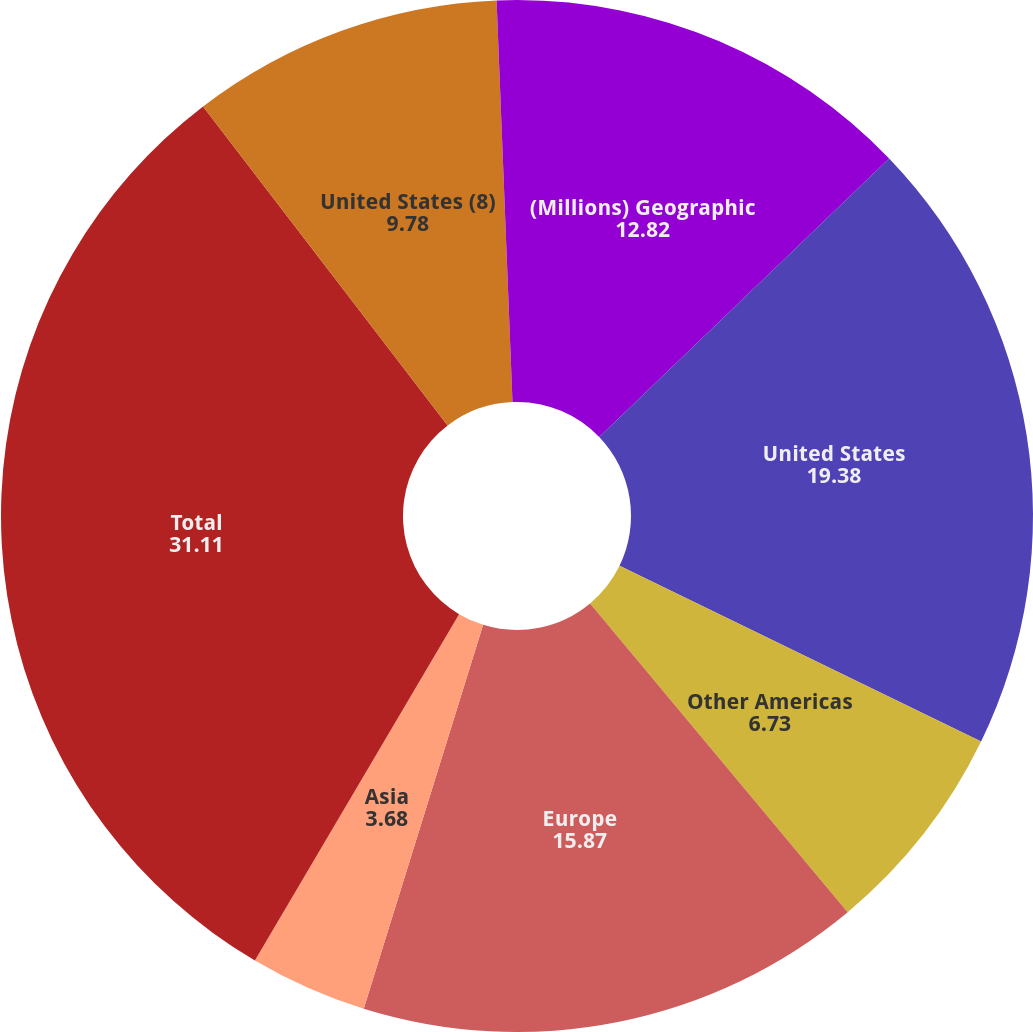Convert chart. <chart><loc_0><loc_0><loc_500><loc_500><pie_chart><fcel>(Millions) Geographic<fcel>United States<fcel>Other Americas<fcel>Europe<fcel>Asia<fcel>Total<fcel>United States (8)<fcel>Europe (9)<nl><fcel>12.82%<fcel>19.38%<fcel>6.73%<fcel>15.87%<fcel>3.68%<fcel>31.11%<fcel>9.78%<fcel>0.63%<nl></chart> 